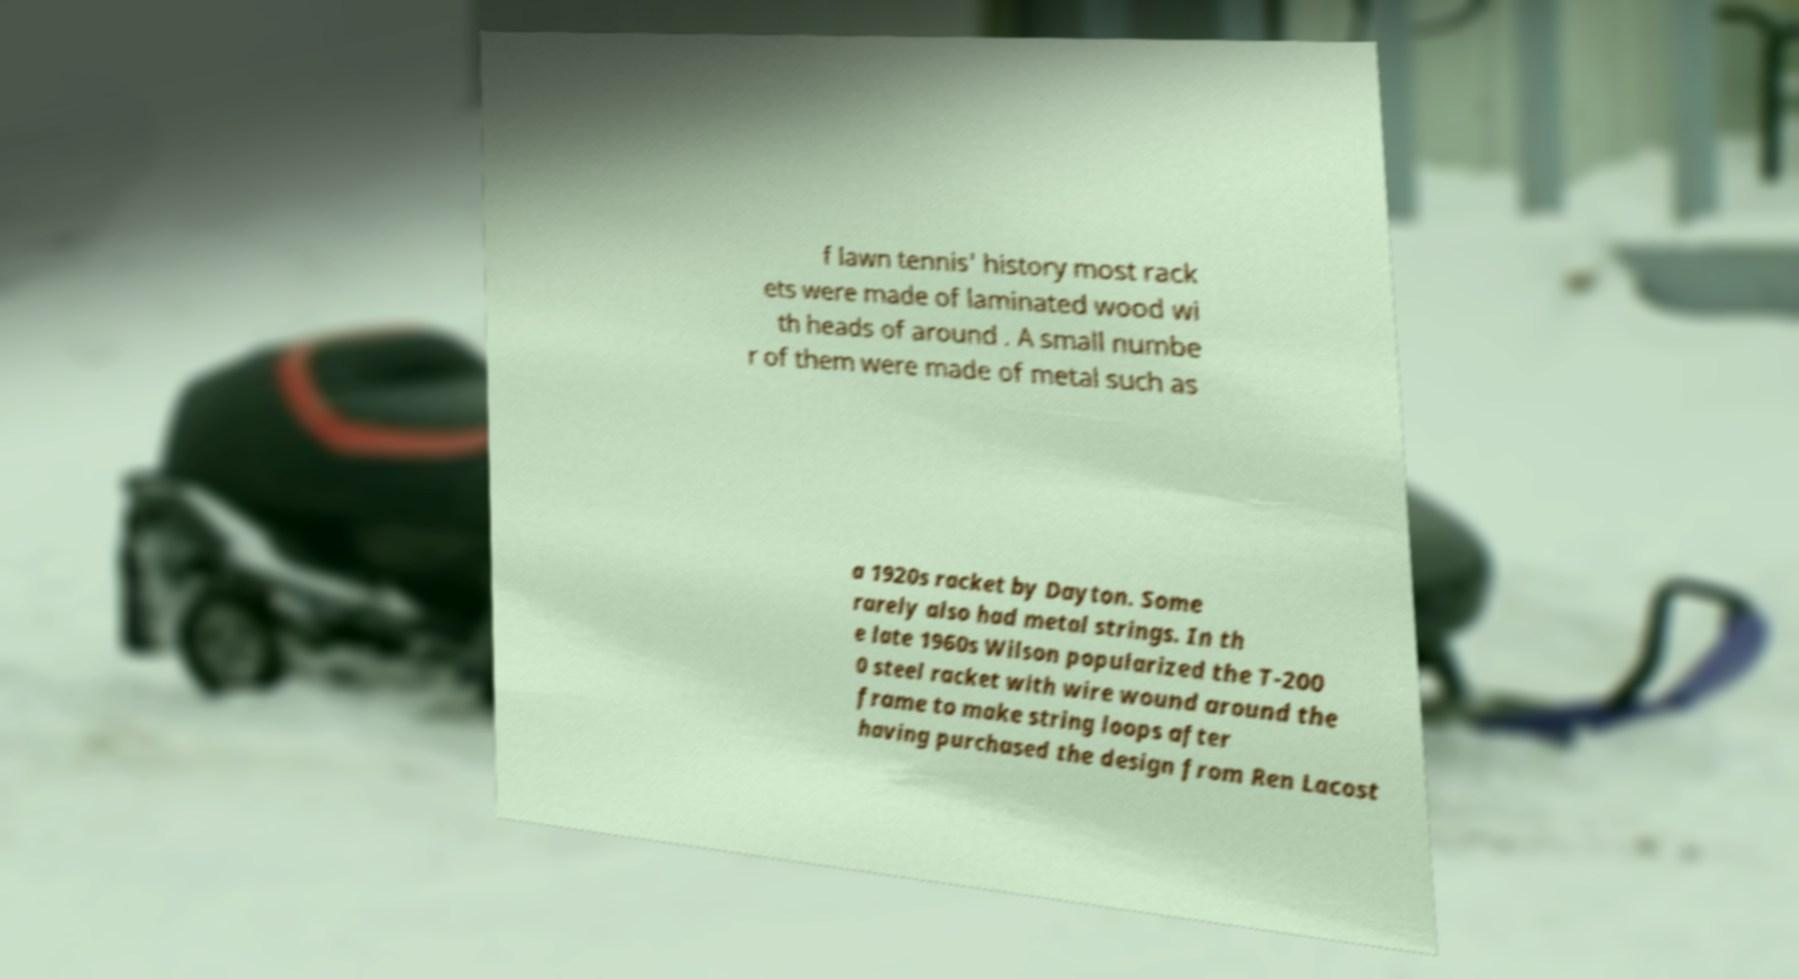What messages or text are displayed in this image? I need them in a readable, typed format. f lawn tennis' history most rack ets were made of laminated wood wi th heads of around . A small numbe r of them were made of metal such as a 1920s racket by Dayton. Some rarely also had metal strings. In th e late 1960s Wilson popularized the T-200 0 steel racket with wire wound around the frame to make string loops after having purchased the design from Ren Lacost 